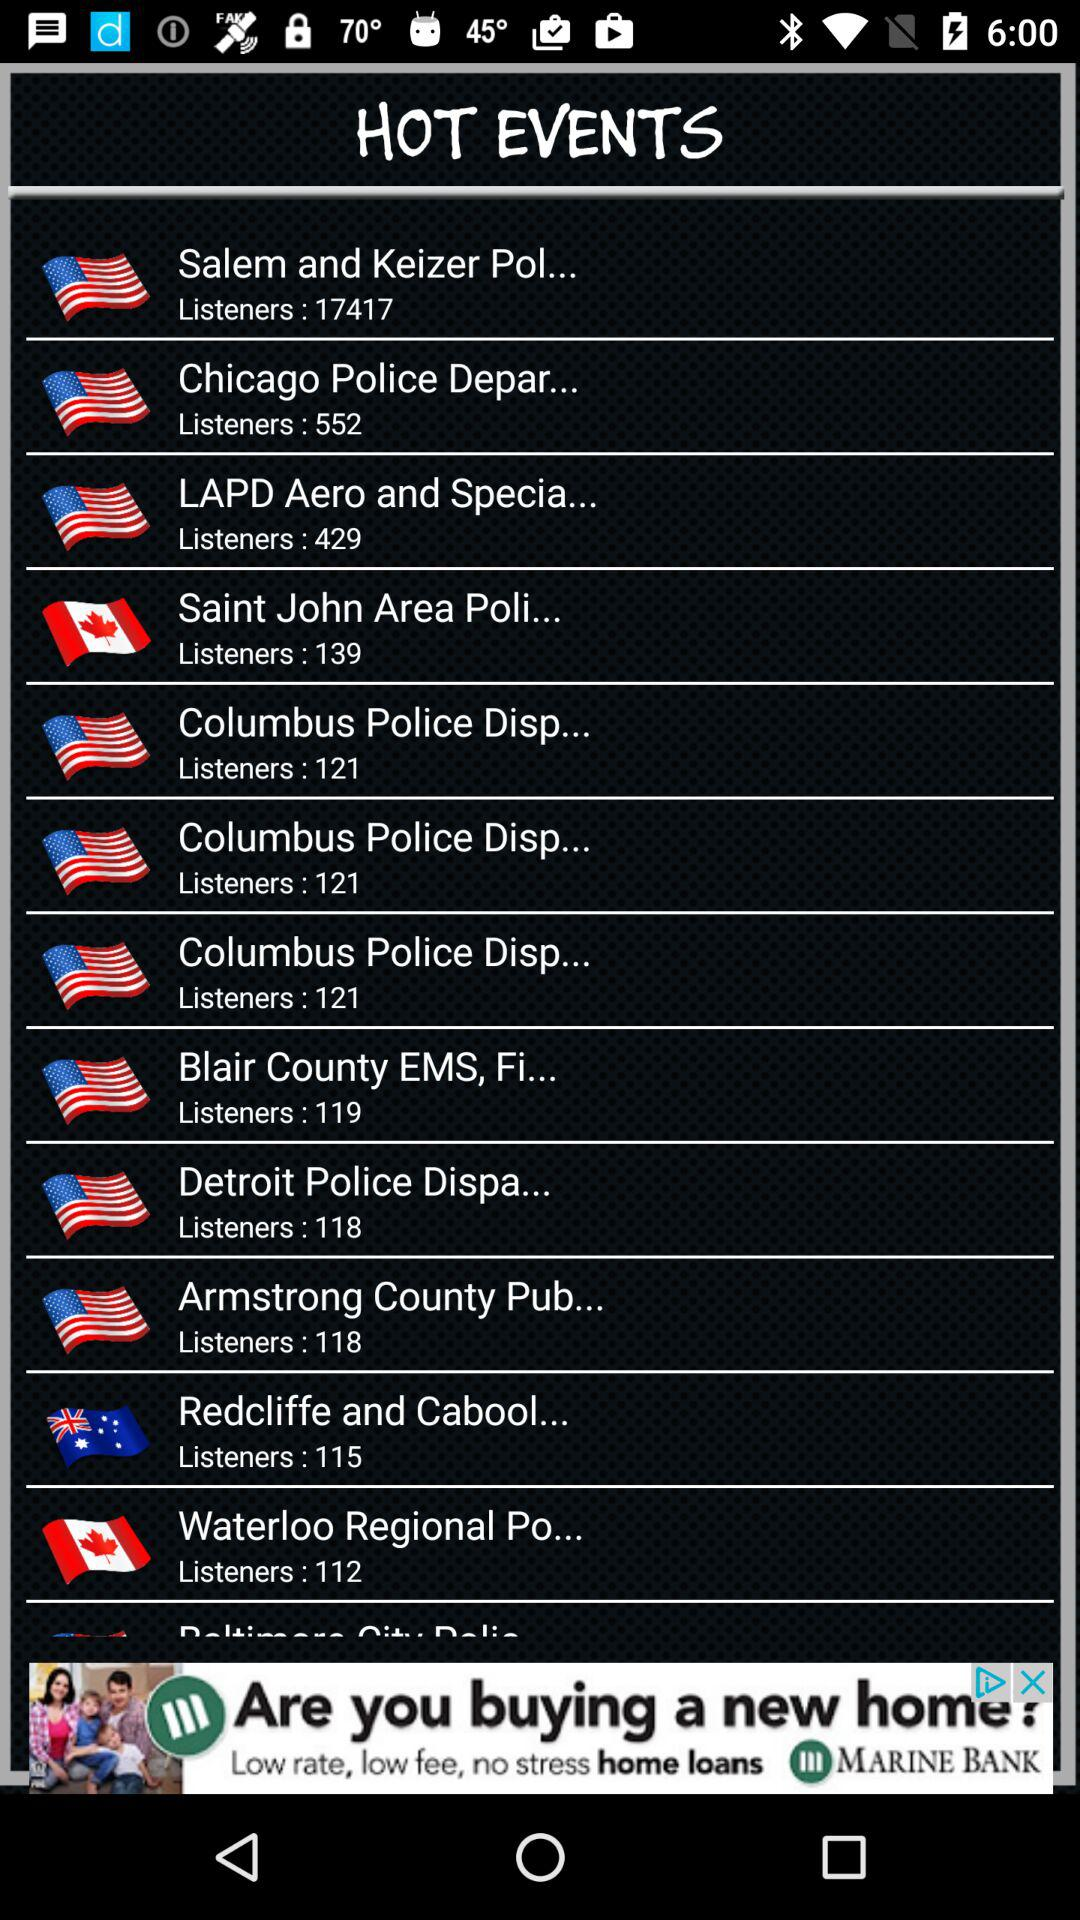What is the number of LAPD listeners? The number of LAPD listeners is 429. 